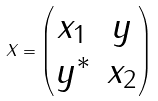<formula> <loc_0><loc_0><loc_500><loc_500>X = \begin{pmatrix} x _ { 1 } & y \\ y ^ { \ast } & x _ { 2 } \end{pmatrix}</formula> 